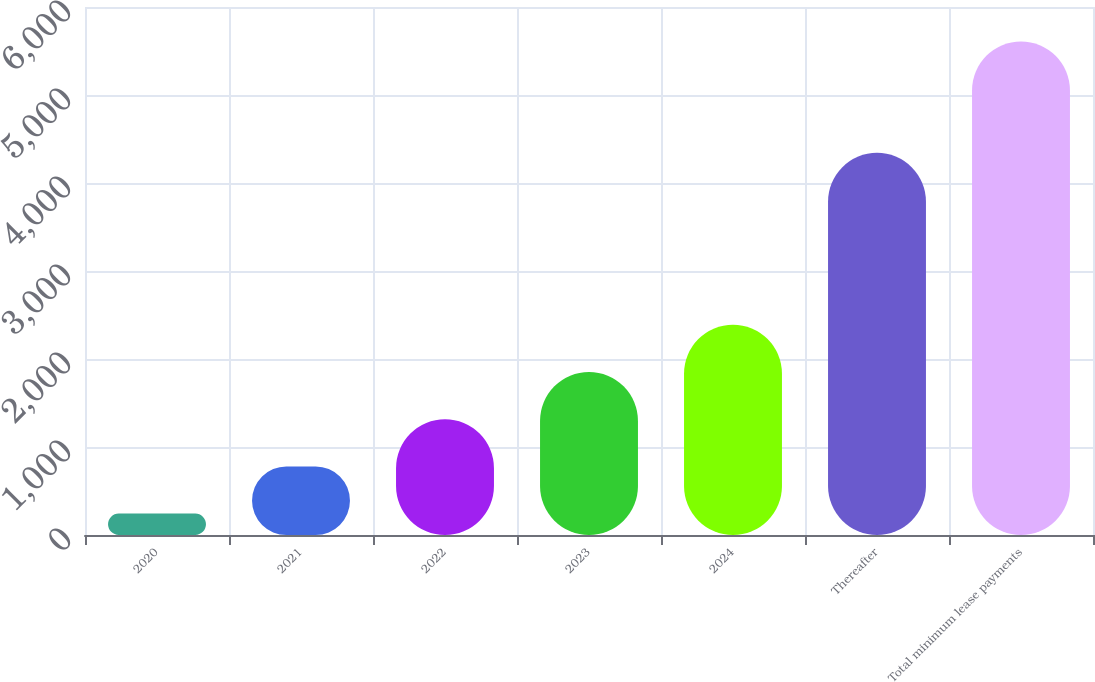<chart> <loc_0><loc_0><loc_500><loc_500><bar_chart><fcel>2020<fcel>2021<fcel>2022<fcel>2023<fcel>2024<fcel>Thereafter<fcel>Total minimum lease payments<nl><fcel>243<fcel>779.5<fcel>1316<fcel>1852.5<fcel>2389<fcel>4343<fcel>5608<nl></chart> 